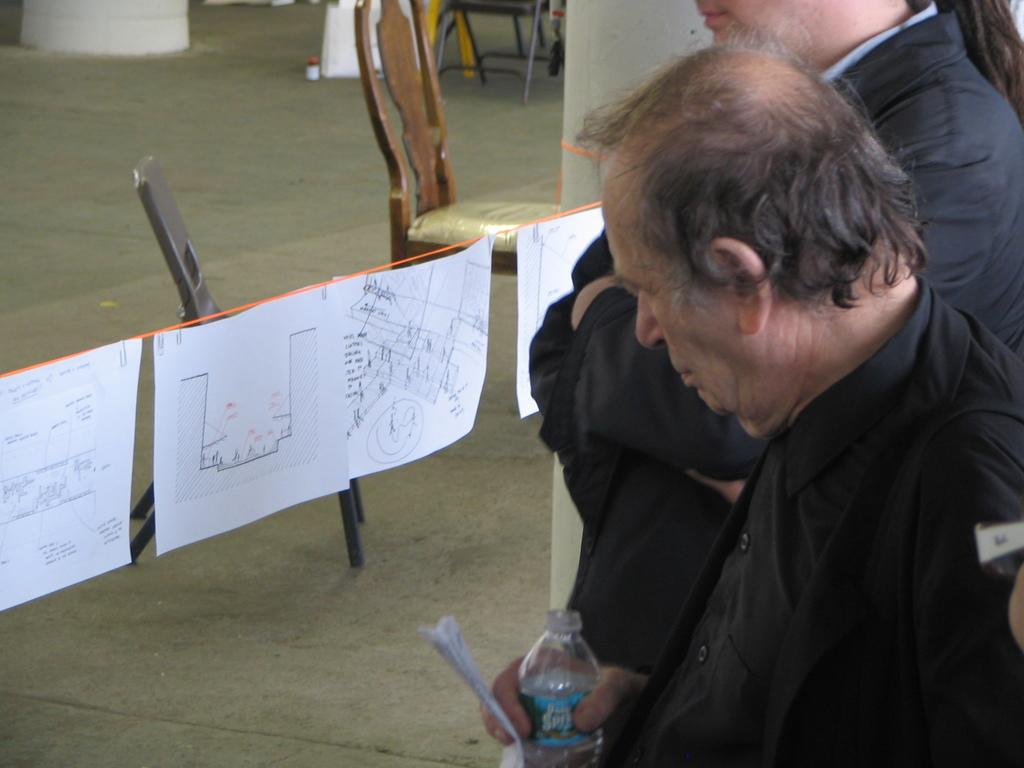Who is present in the image? There are people in the image. What is the man holding in the image? The man is holding a bottle. What else can be seen in the image besides people? There are papers visible in the image. What type of furniture is present in the image? There are chairs in the image. What type of soda is the man drinking from the bottle in the image? The image does not show the man drinking from the bottle, nor does it specify the type of liquid inside the bottle. What decision is being made by the people in the image? The image does not provide any information about a decision being made by the people. 